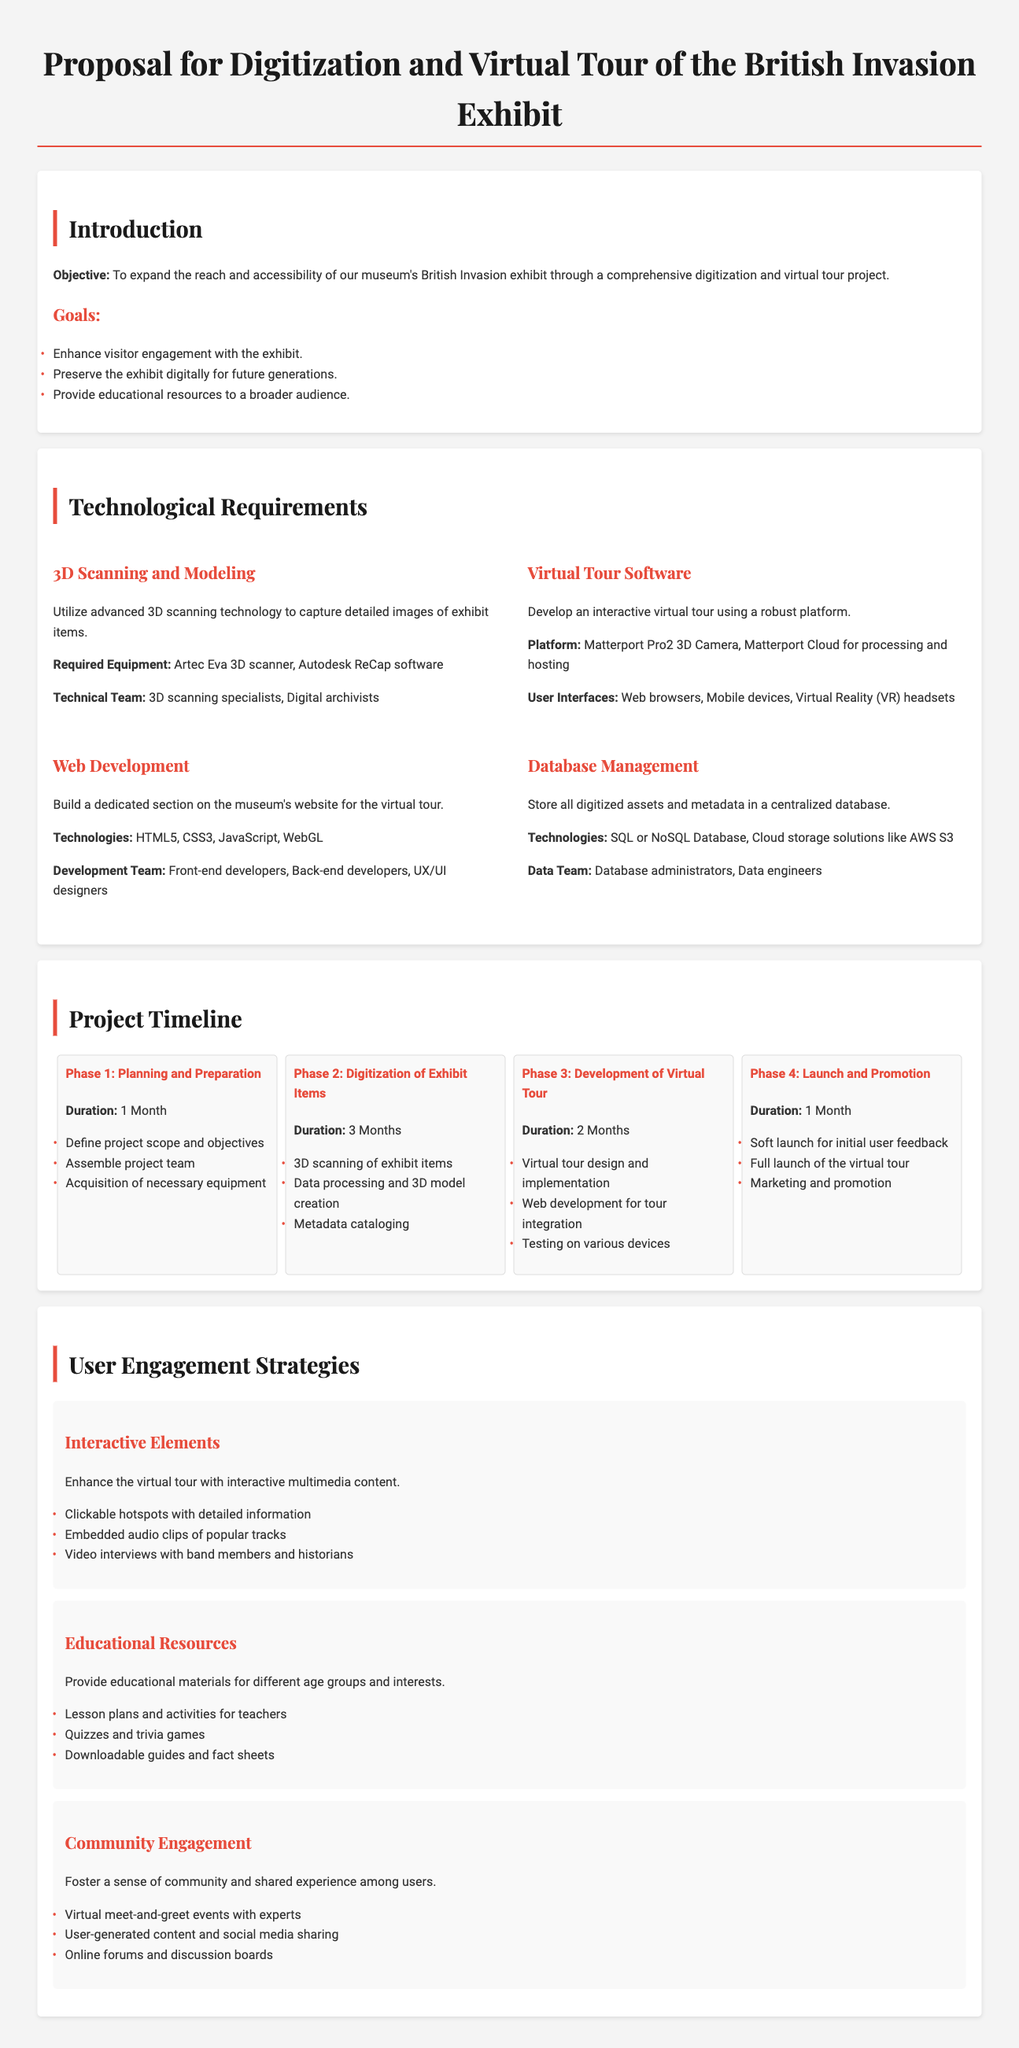What is the primary objective of the proposal? The primary objective is to expand the reach and accessibility of the British Invasion exhibit through digitization and a virtual tour project.
Answer: Expand the reach and accessibility What technology is used for 3D scanning? The document specifies the Artec Eva 3D scanner for 3D scanning.
Answer: Artec Eva 3D scanner How long is the planning phase? According to the project timeline, the planning phase lasts one month.
Answer: 1 Month Which software is used for the virtual tour? The proposal mentions Matterport as the platform for the virtual tour.
Answer: Matterport What is one type of interactive element planned for user engagement? The proposal lists clickable hotspots as one interactive element.
Answer: Clickable hotspots How many phases are in the project timeline? The project timeline consists of four distinct phases.
Answer: 4 What is included in the educational resources? The proposal states lesson plans, quizzes, and downloadable guides are included.
Answer: Lesson plans and activities Who will lead the development team? The document mentions that front-end developers, back-end developers, and UX/UI designers will lead the development team.
Answer: Front-end developers, Back-end developers, UX/UI designers What will happen during the soft launch? The soft launch will gather initial user feedback according to the project description.
Answer: Initial user feedback 